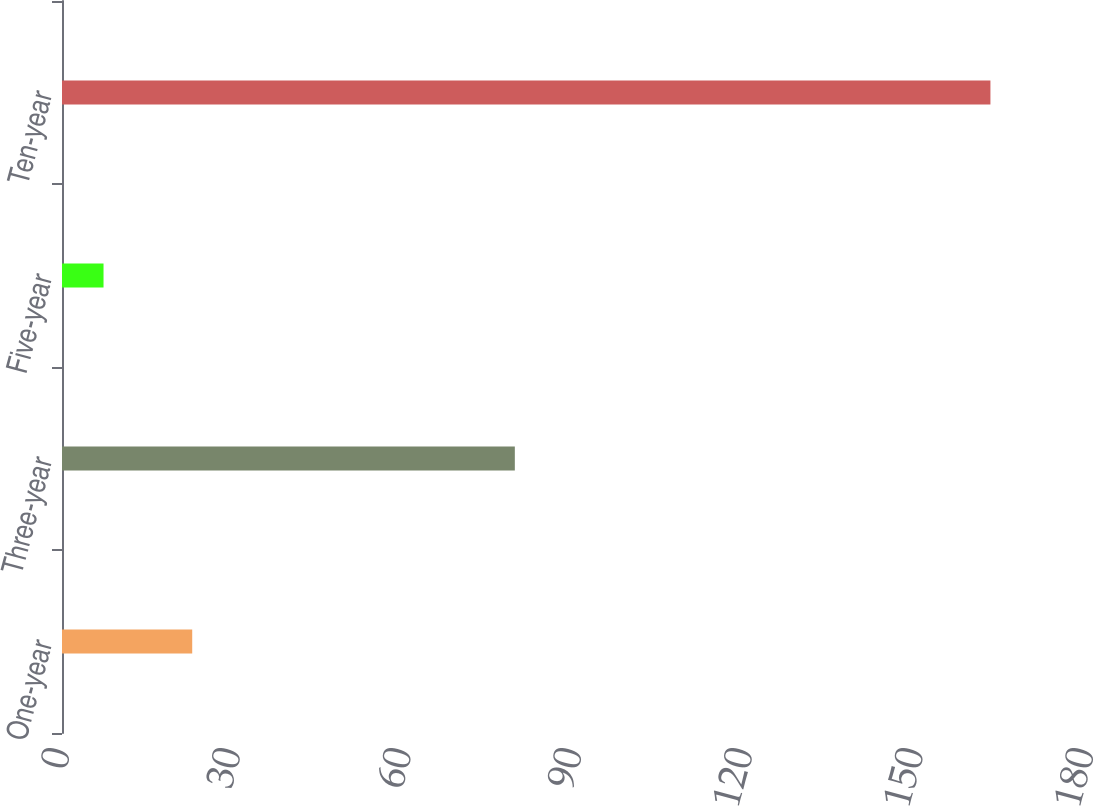<chart> <loc_0><loc_0><loc_500><loc_500><bar_chart><fcel>One-year<fcel>Three-year<fcel>Five-year<fcel>Ten-year<nl><fcel>22.89<fcel>79.6<fcel>7.3<fcel>163.2<nl></chart> 